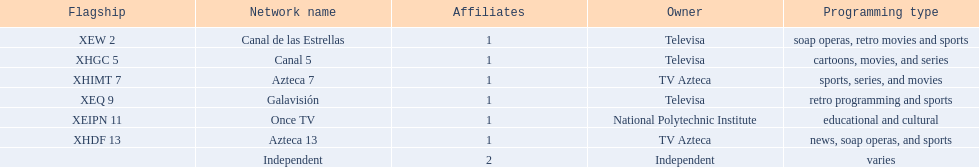Who is the only network owner listed in a consecutive order in the chart? Televisa. 